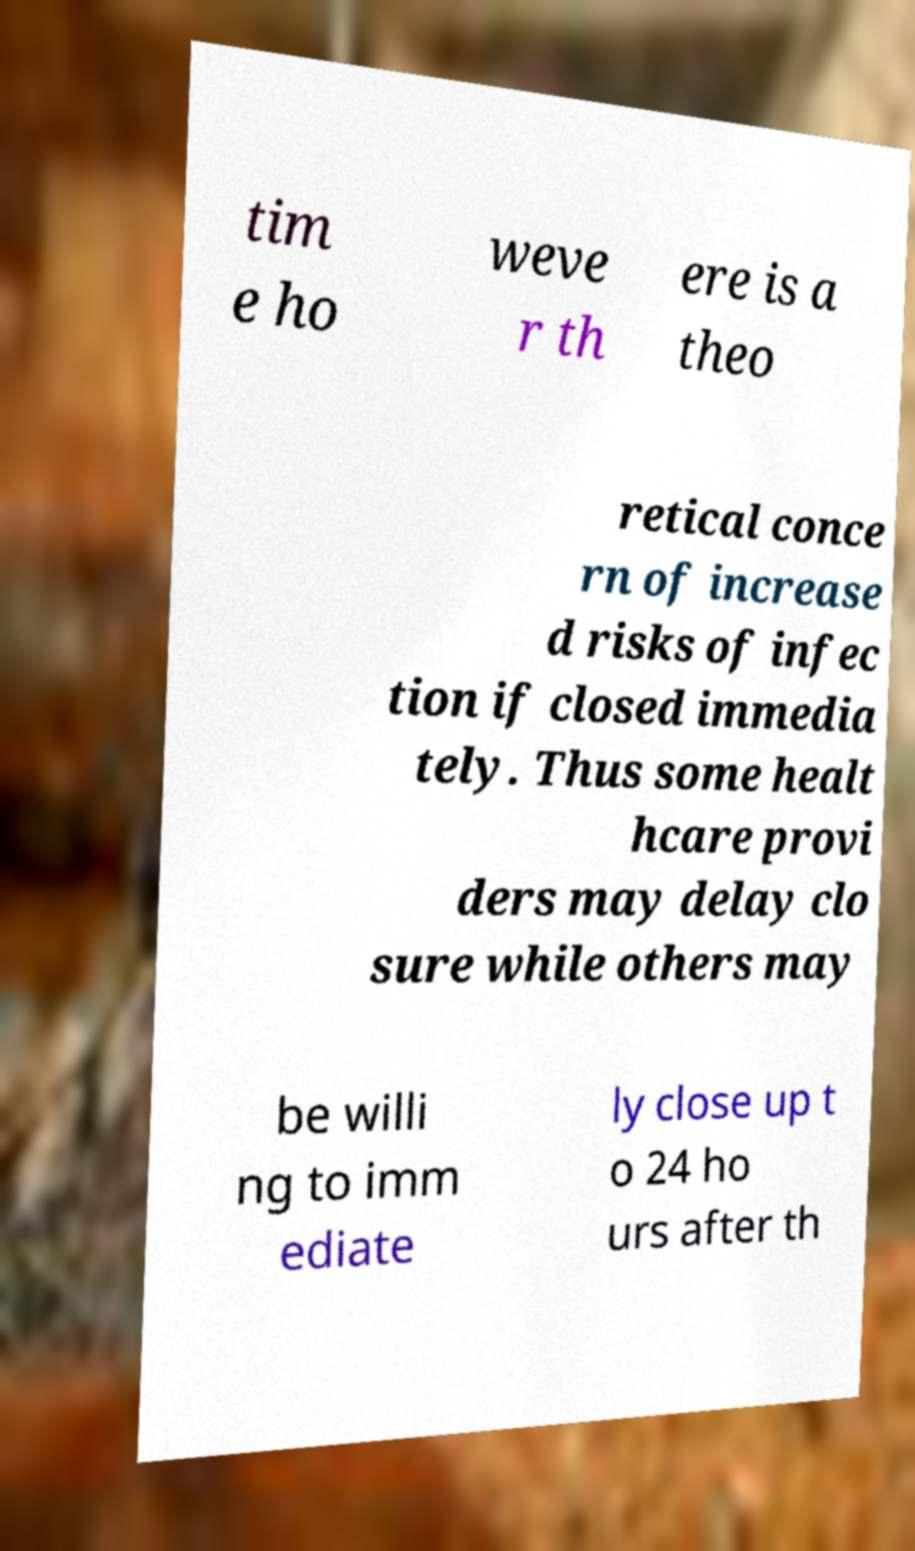Please identify and transcribe the text found in this image. tim e ho weve r th ere is a theo retical conce rn of increase d risks of infec tion if closed immedia tely. Thus some healt hcare provi ders may delay clo sure while others may be willi ng to imm ediate ly close up t o 24 ho urs after th 